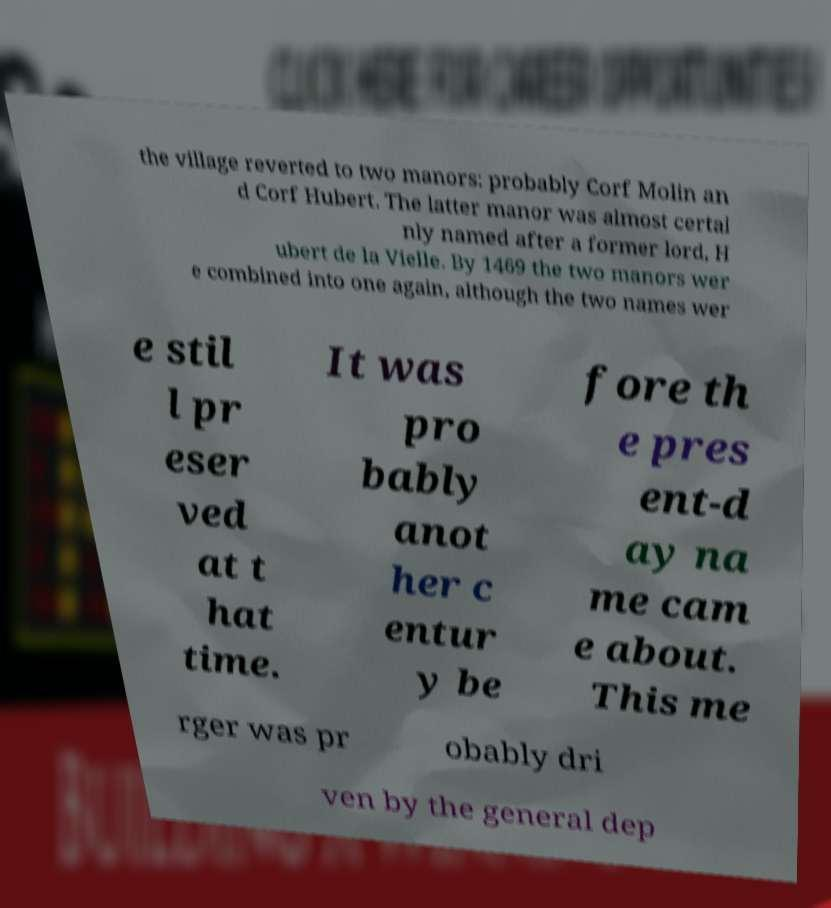Please identify and transcribe the text found in this image. the village reverted to two manors: probably Corf Molin an d Corf Hubert. The latter manor was almost certai nly named after a former lord, H ubert de la Vielle. By 1469 the two manors wer e combined into one again, although the two names wer e stil l pr eser ved at t hat time. It was pro bably anot her c entur y be fore th e pres ent-d ay na me cam e about. This me rger was pr obably dri ven by the general dep 